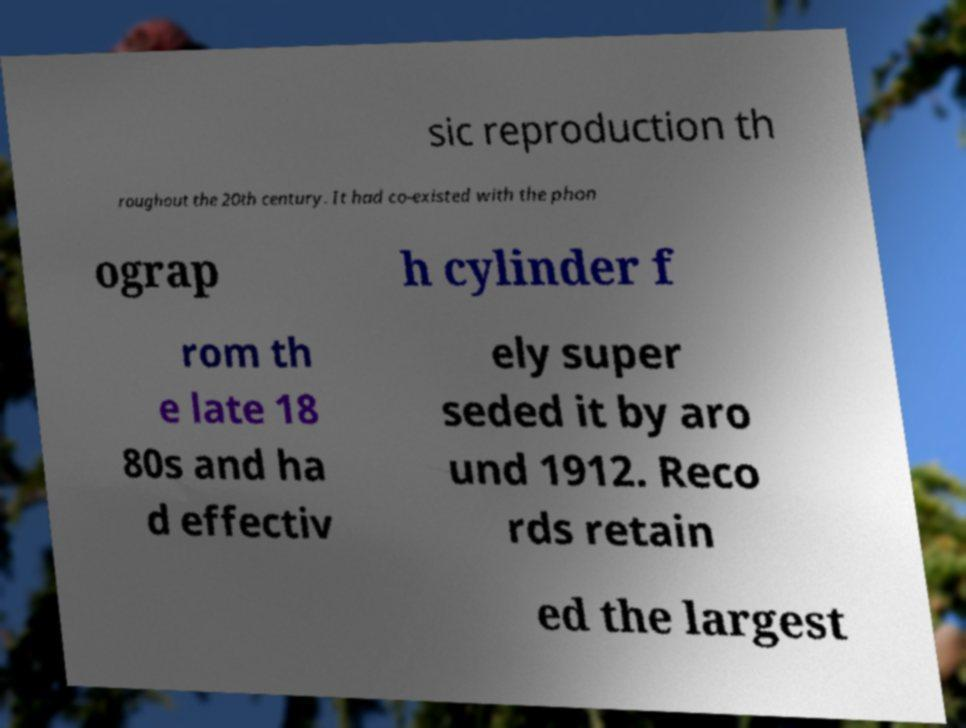What messages or text are displayed in this image? I need them in a readable, typed format. sic reproduction th roughout the 20th century. It had co-existed with the phon ograp h cylinder f rom th e late 18 80s and ha d effectiv ely super seded it by aro und 1912. Reco rds retain ed the largest 